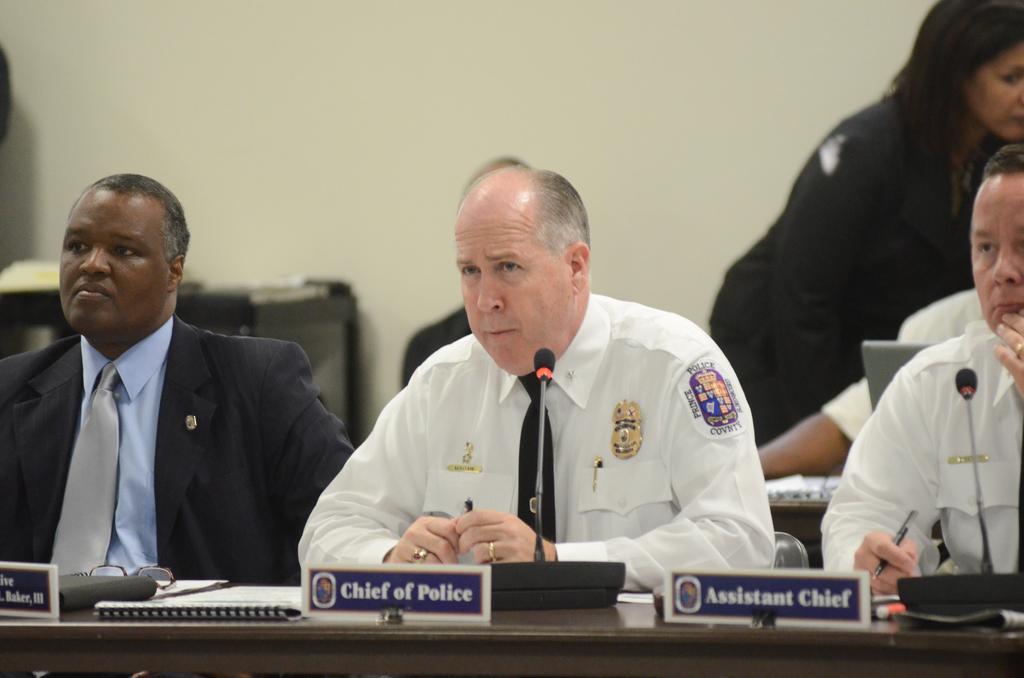How would you summarize this image in a sentence or two? In this picture we can see people, in front of them we can see my, name boards and some objects and in the background we can see the wall. 